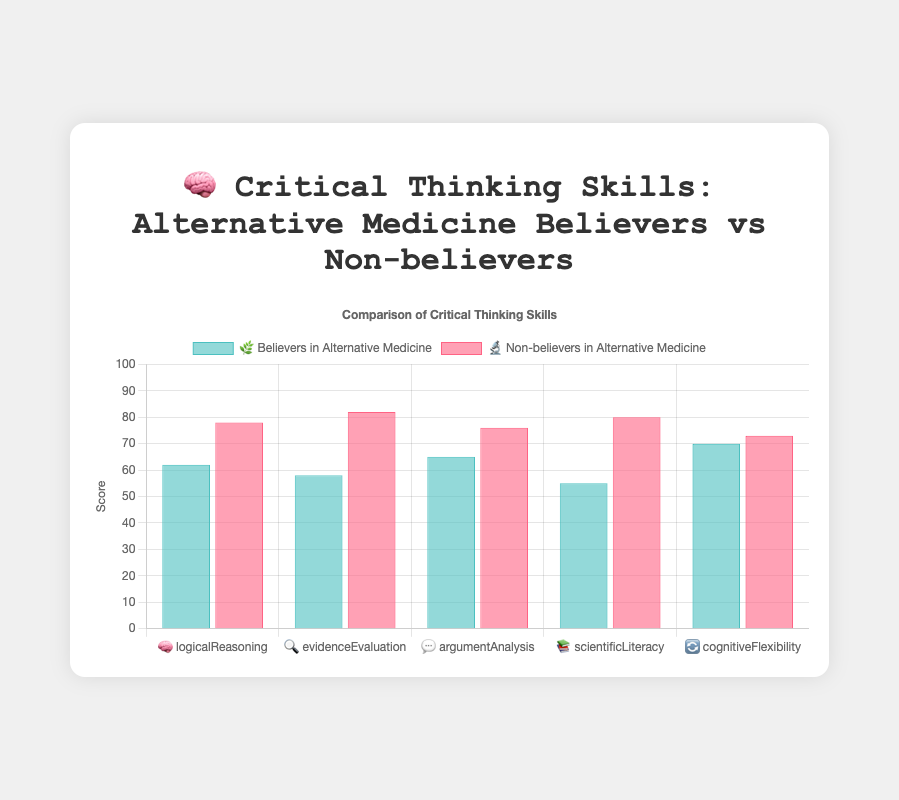Which group has a higher score in logical reasoning 🧠? Believers in Alternative Medicine have a logical reasoning score of 62, while Non-believers have a score of 78. By comparing these two values, Non-believers have a higher score.
Answer: Non-believers What is the difference in evidence evaluation 🔍 scores between believers and non-believers? The evidence evaluation score for Believers is 58 and for Non-believers is 82. The difference can be calculated as 82 - 58.
Answer: 24 What is the average critical thinking score for Non-believers 🔬? Non-believers have scores of 78 (logical reasoning), 82 (evidence evaluation), 76 (argument analysis), 80 (scientific literacy), and 73 (cognitive flexibility). Summing these gives 389. Dividing by 5 (the number of skills) gives the average: 389 / 5 = 77.8.
Answer: 77.8 Which group has the lowest scientific literacy 📚 score? Believers in Alternative Medicine have a scientific literacy score of 55, while Non-believers have a score of 80. By comparing these scores, Believers have the lower score.
Answer: Believers Compare the cognitive flexibility 🔄 scores and indicate which is higher. Believers have a cognitive flexibility score of 70 and Non-believers have a score of 73. Thus, Non-believers have a higher cognitive flexibility score.
Answer: Non-believers Which skill shows the greatest difference overall between the two groups? The differences in scores for each skill are: Logical Reasoning = 16, Evidence Evaluation = 24, Argument Analysis = 11, Scientific Literacy = 25, Cognitive Flexibility = 3. The maximum difference is in Scientific Literacy with a difference of 25.
Answer: Scientific Literacy How do the average scores of all skills differ between the two groups? Believers' scores are 62, 58, 65, 55, 70, summing to 310, and averaging to 310 / 5 = 62. Non-believers' scores are 78, 82, 76, 80, 73, summing to 389, and averaging to 389 / 5 = 77.8. Comparing the averages, the difference is 77.8 - 62 = 15.8.
Answer: 15.8 Which group has a higher score in argument analysis 💬 and what is the difference? Believers have a score of 65 and Non-believers have a score of 76. Non-believers have the higher score, and the difference is 76 - 65.
Answer: Non-believers, 11 What is the range of scores for Believers across all skills? The scores for Believers are 62, 58, 65, 55, 70. The range is calculated as the difference between the highest (70) and lowest (55) scores: 70 - 55.
Answer: 15 